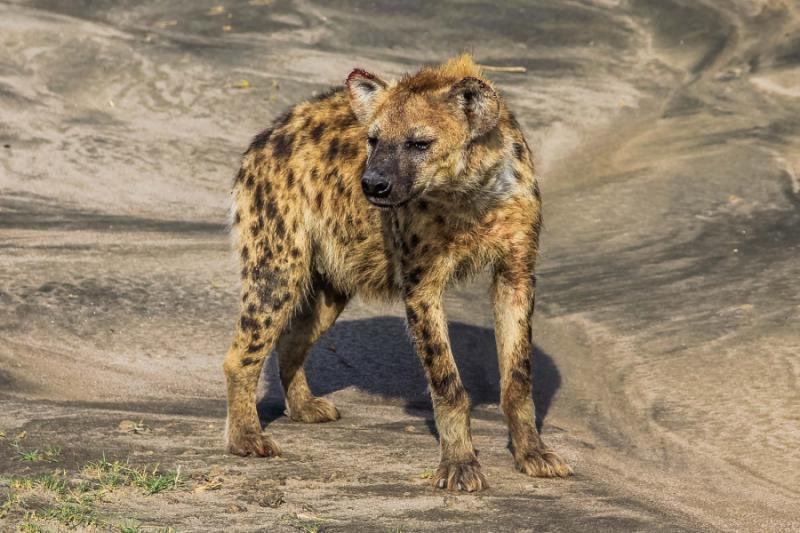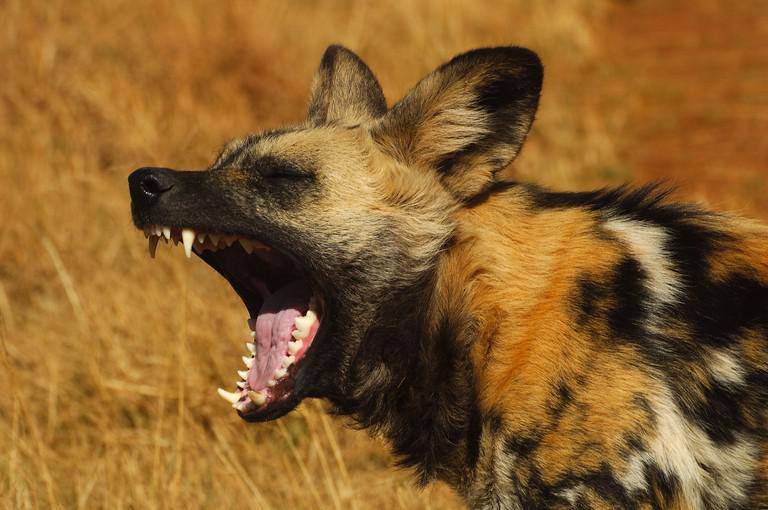The first image is the image on the left, the second image is the image on the right. Analyze the images presented: Is the assertion "One image shows exactly three hyenas standing with bodies turned leftward, some with heads craning to touch one of the others." valid? Answer yes or no. No. The first image is the image on the left, the second image is the image on the right. Assess this claim about the two images: "there is a hyena on brown grass with its mmouth open exposing the top and bottom teeth from the side view". Correct or not? Answer yes or no. Yes. 